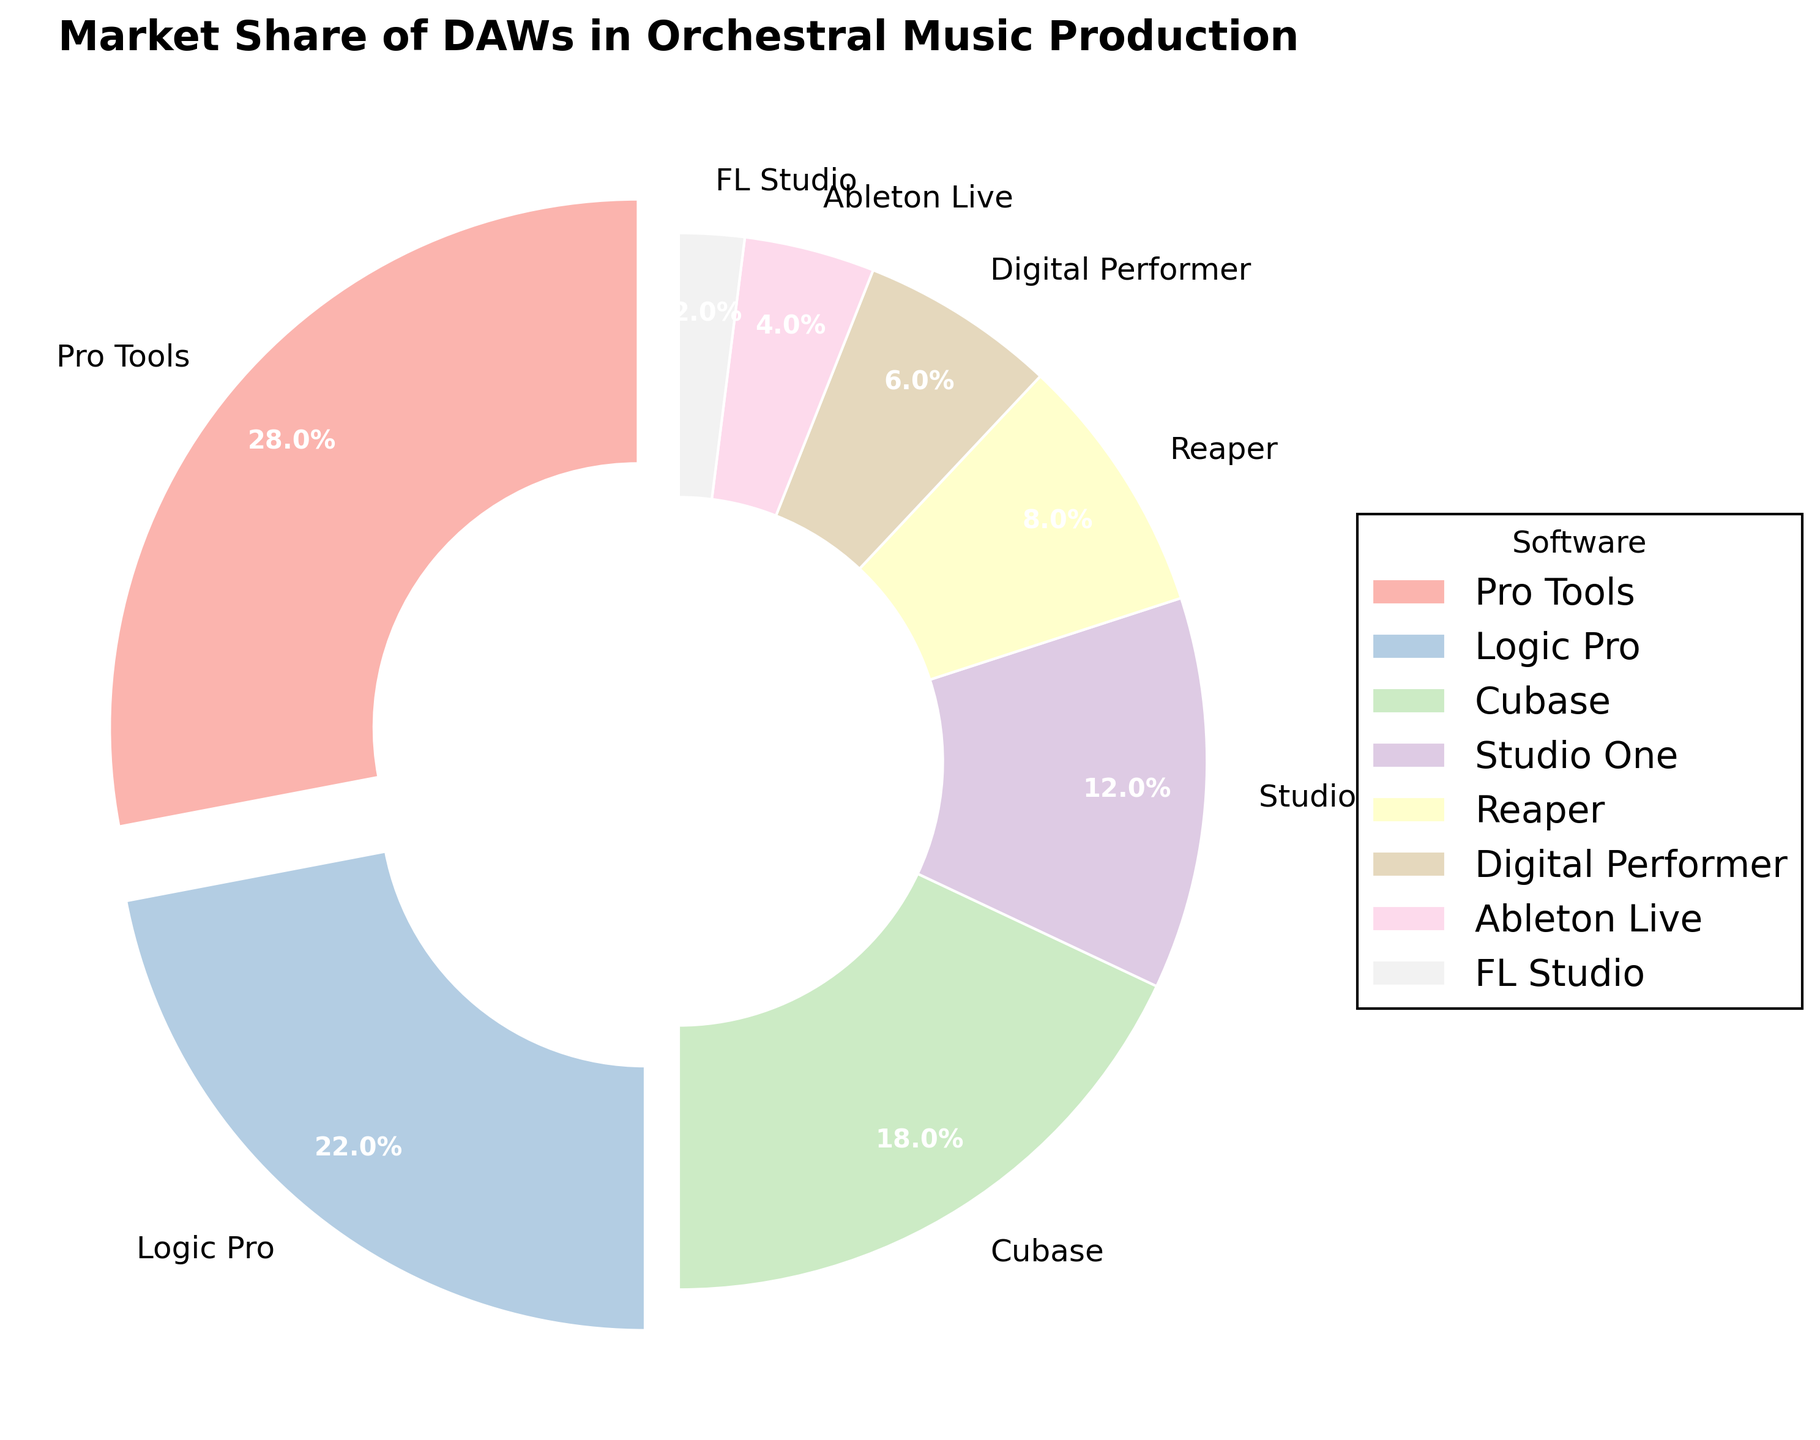Which DAW has the largest market share? The largest segment in the pie chart is labeled "Pro Tools," with 28% of the market share.
Answer: Pro Tools By how much is Pro Tools' market share larger than Logic Pro's? Pro Tools has 28% market share and Logic Pro has 22%. The difference is 28 - 22 = 6%.
Answer: 6% What is the combined market share of Cubase and Studio One? Cubase has 18% and Studio One has 12%. Summing these gives 18 + 12 = 30%.
Answer: 30% Which DAWs have a market share of less than 10%? The segments showing market share less than 10% are labeled "Reaper," "Digital Performer," "Ableton Live," and "FL Studio" with 8%, 6%, 4%, and 2%, respectively.
Answer: Reaper, Digital Performer, Ableton Live, FL Studio How much more popular is Pro Tools compared to FL Studio? Pro Tools has 28% market share and FL Studio has 2%. The difference is 28 - 2 = 26%.
Answer: 26% Which DAW is shown with the most explosive visual effect in the pie chart? The pie chart uses an explode effect for segments where the market share is greater than 20%. The segment for "Pro Tools" is the most visually prominent due to the largest explode effect.
Answer: Pro Tools Out of the DAWs displayed, which has the smallest market share, and what is it? The smallest segment in the pie chart is labeled "FL Studio" with 2%.
Answer: FL Studio, 2% Which two DAWs together account for nearly half of the market? Summing the market shares of Pro Tools (28%) and Logic Pro (22%) gives 28 + 22 = 50%, which is nearly half of the market.
Answer: Pro Tools and Logic Pro Comparing Reaper and Digital Performer, which one is more popular, and by how much? Reaper has 8% market share, while Digital Performer has 6%. The difference is 8 - 6 = 2%.
Answer: Reaper, 2% What color represents Ableton Live in the pie chart? The color scheme of the pie chart uses pastel colors, and the segment labeled "Ableton Live" is generally light-colored. Viewer discretion for exact color may vary, but it's a specific pastel hue.
Answer: Pastel (light color) 